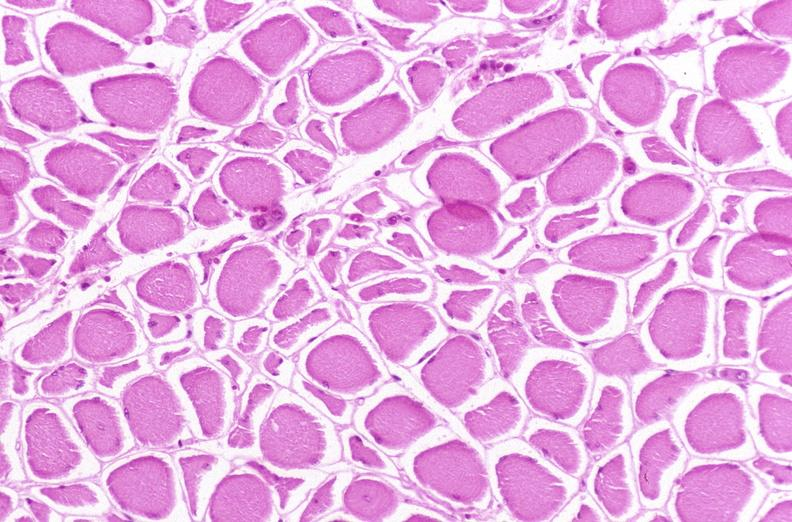does this image show skeletal muscle, atrophy due to immobilization cast?
Answer the question using a single word or phrase. Yes 